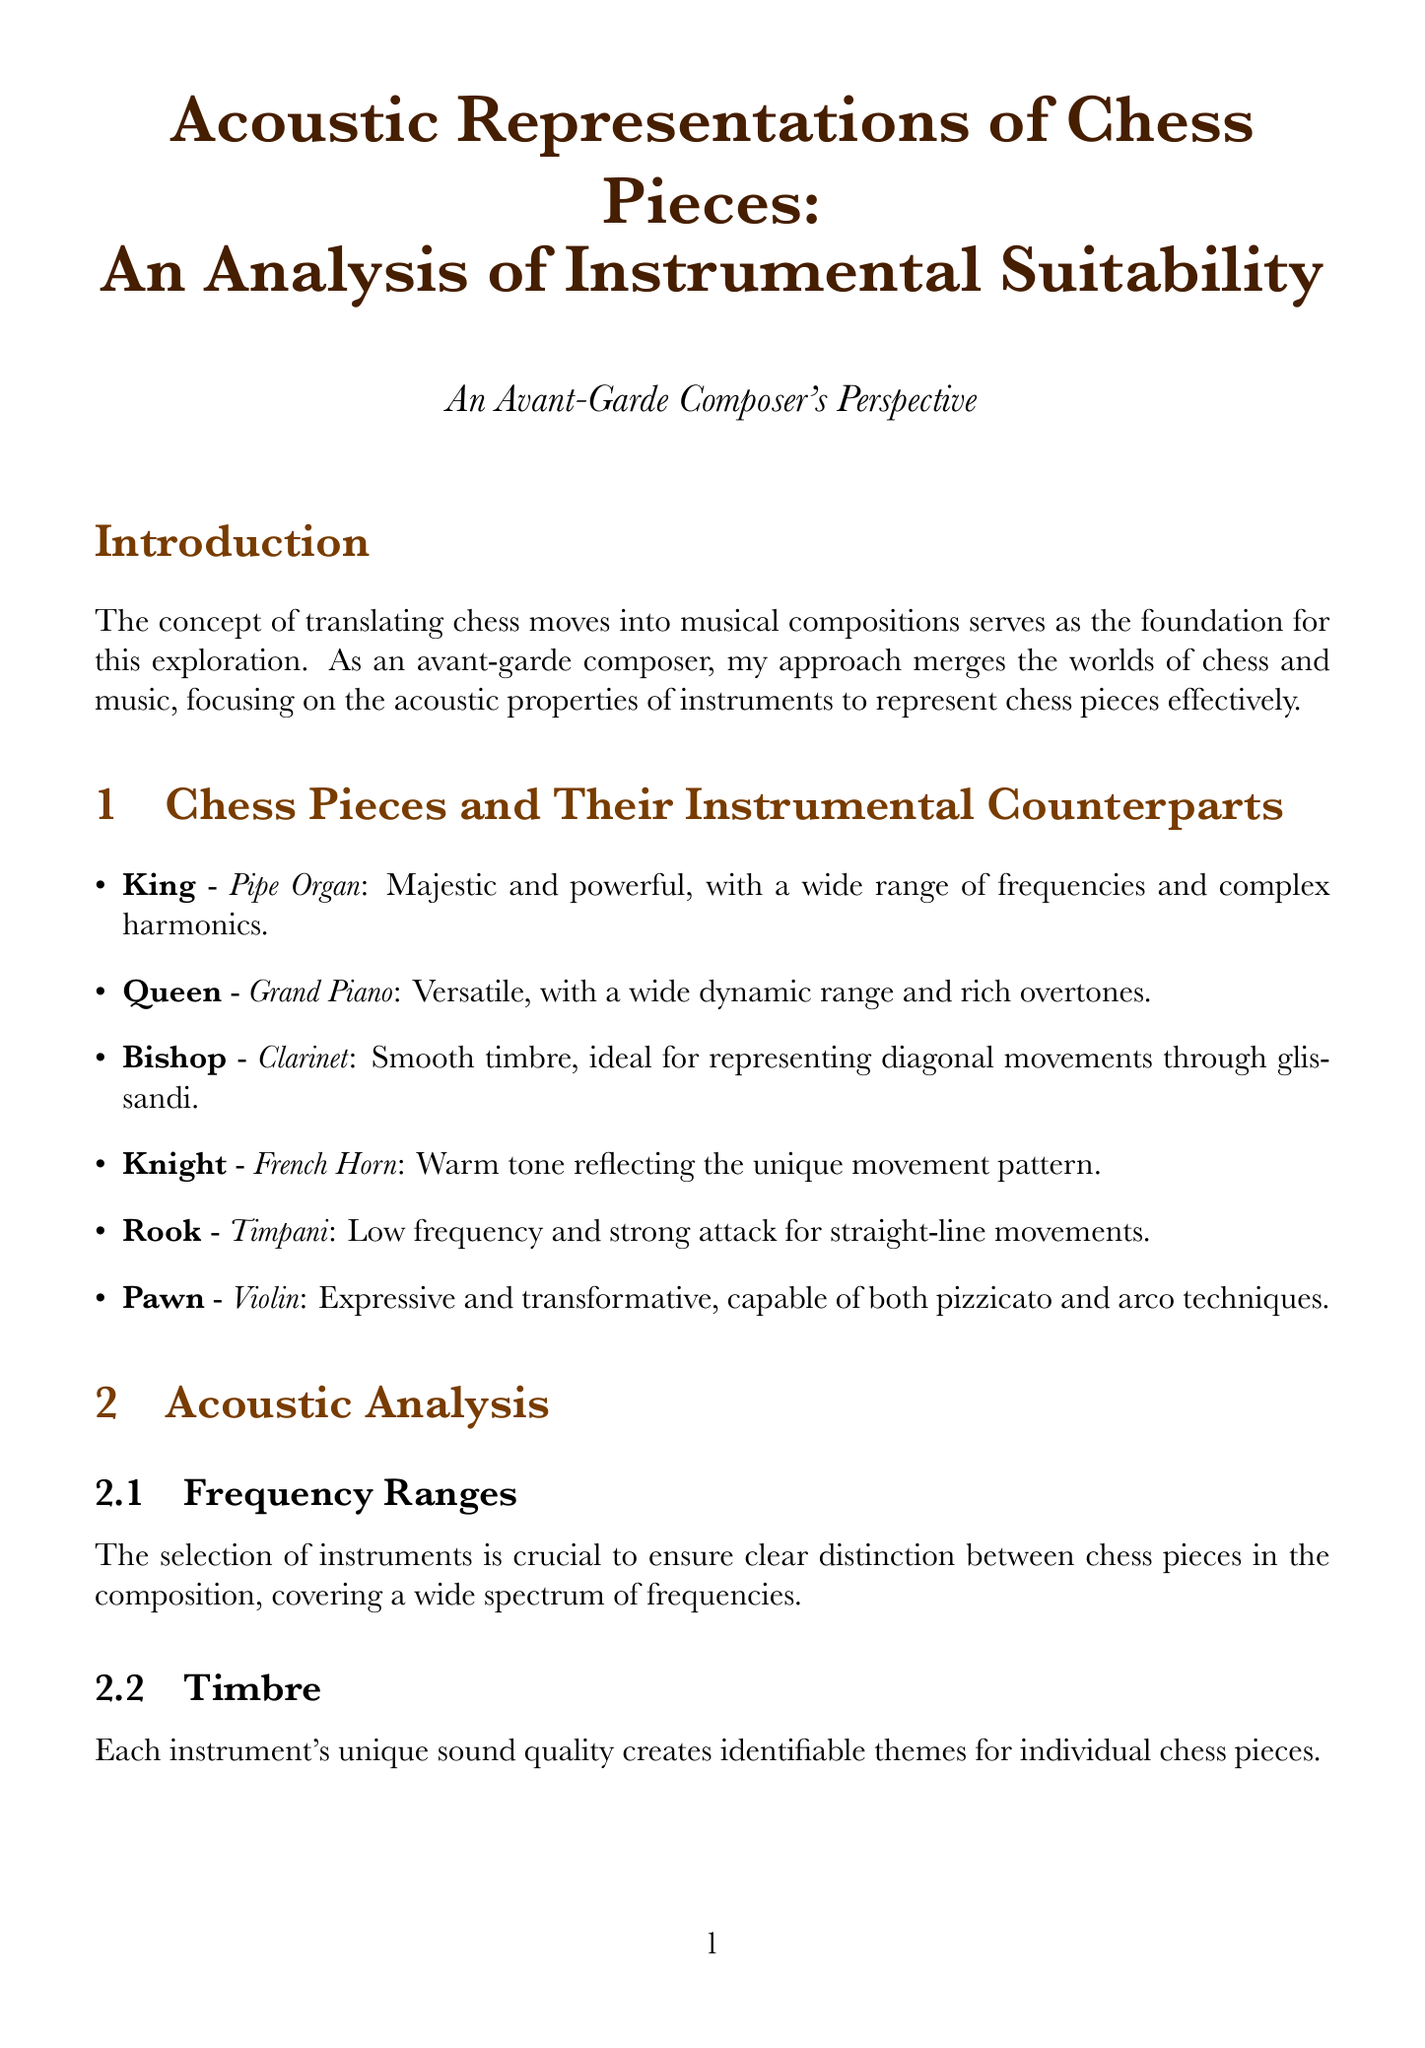What is the title of the report? The title of the report is stated at the top of the document.
Answer: Acoustic Representations of Chess Pieces: An Analysis of Instrumental Suitability Which instrument is associated with the King? The report lists specific instruments corresponding to each chess piece, including the King.
Answer: Pipe Organ What is the rationale for using the Grand Piano for the Queen? The rationale for each instrument is provided to explain its suitability for the corresponding chess piece.
Answer: Versatile and capable of covering large musical territory What playing technique is suggested for the Pawn? The report specifies various playing techniques available for each instrument, including that for the Pawn.
Answer: Pizzicato and arco Which chess piece is represented by the Timpani? The chess pieces are matched with instruments in the document, including the one represented by the Timpani.
Answer: Rook What compositional technique involves assigning specific themes? The document explains different compositional techniques that can be used in the music.
Answer: Leitmotif What is the significance of frequency ranges in instrument selection? The document discusses the importance of frequency coverage for distinguishing chess pieces in composition.
Answer: Ensuring clear distinction between chess pieces in the composition In which game did unexpected instrumental outbursts occur? The report analyzes specific games and their musical interpretations, highlighting key moments.
Answer: Opera House Game: Levitsky vs. Marshall (1912) What future explorations are suggested regarding music composition? The conclusion of the report mentions potential future directions for the analysis.
Answer: Electronic and synthesized sounds in representing AI chess engines 